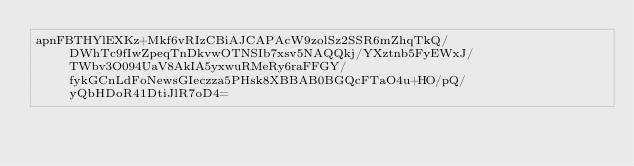Convert code to text. <code><loc_0><loc_0><loc_500><loc_500><_SML_>apnFBTHYlEXKz+Mkf6vRIzCBiAJCAPAcW9zolSz2SSR6mZhqTkQ/DWhTc9fIwZpeqTnDkvwOTNSIb7xsv5NAQQkj/YXztnb5FyEWxJ/TWbv3O094UaV8AkIA5yxwuRMeRy6raFFGY/fykGCnLdFoNewsGIeczza5PHsk8XBBAB0BGQcFTaO4u+HO/pQ/yQbHDoR41DtiJlR7oD4=</code> 